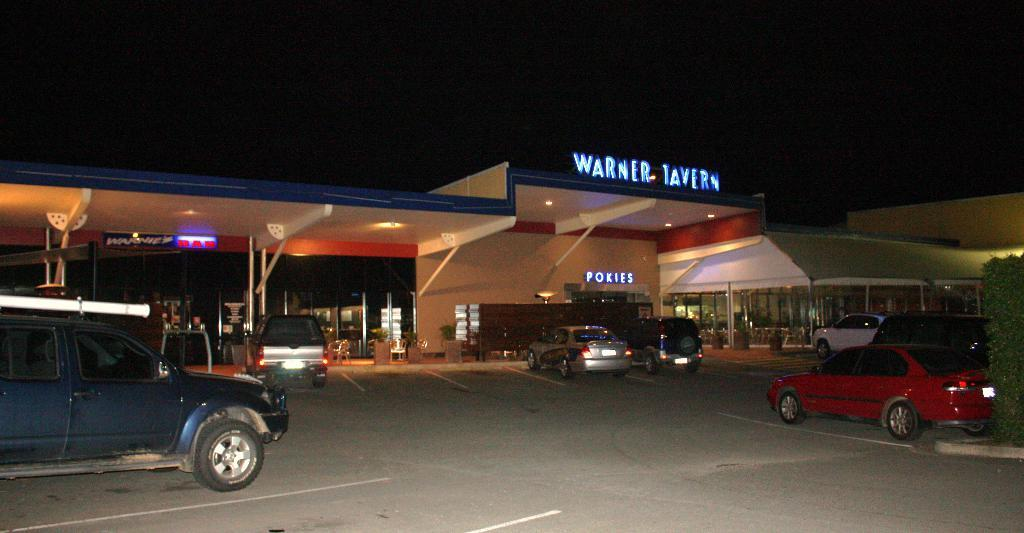What types of vehicles can be seen in the image? There are many vehicles of different colors in the image. What structure is present in the image? There is a building in the image. What type of text is visible in the image? There is LED text in the image. What type of vegetation is present in the image? There are plants in the image. What type of pathway is present in the image? There is a road in the image. How would you describe the sky in the image? The sky is dark in the image. Where is the zoo located in the image? There is no zoo present in the image. What type of impulse can be seen affecting the vehicles in the image? There is no impulse affecting the vehicles in the image; they are stationary. Can you tell me the name of the judge in the image? There is no judge present in the image. 